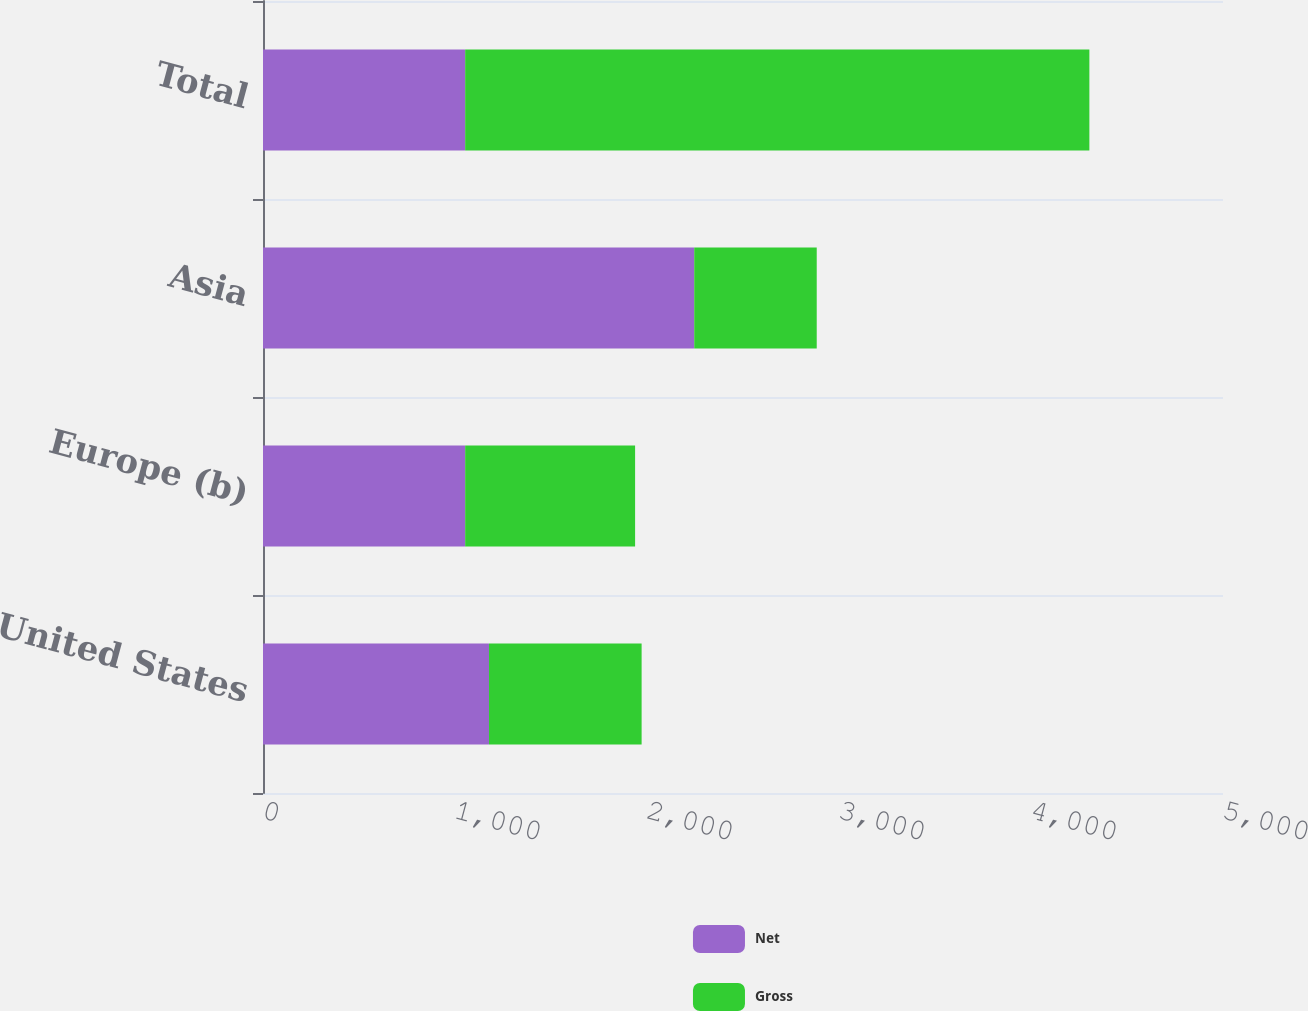Convert chart to OTSL. <chart><loc_0><loc_0><loc_500><loc_500><stacked_bar_chart><ecel><fcel>United States<fcel>Europe (b)<fcel>Asia<fcel>Total<nl><fcel>Net<fcel>1177<fcel>1053<fcel>2246<fcel>1053<nl><fcel>Gross<fcel>795<fcel>885<fcel>638<fcel>3251<nl></chart> 